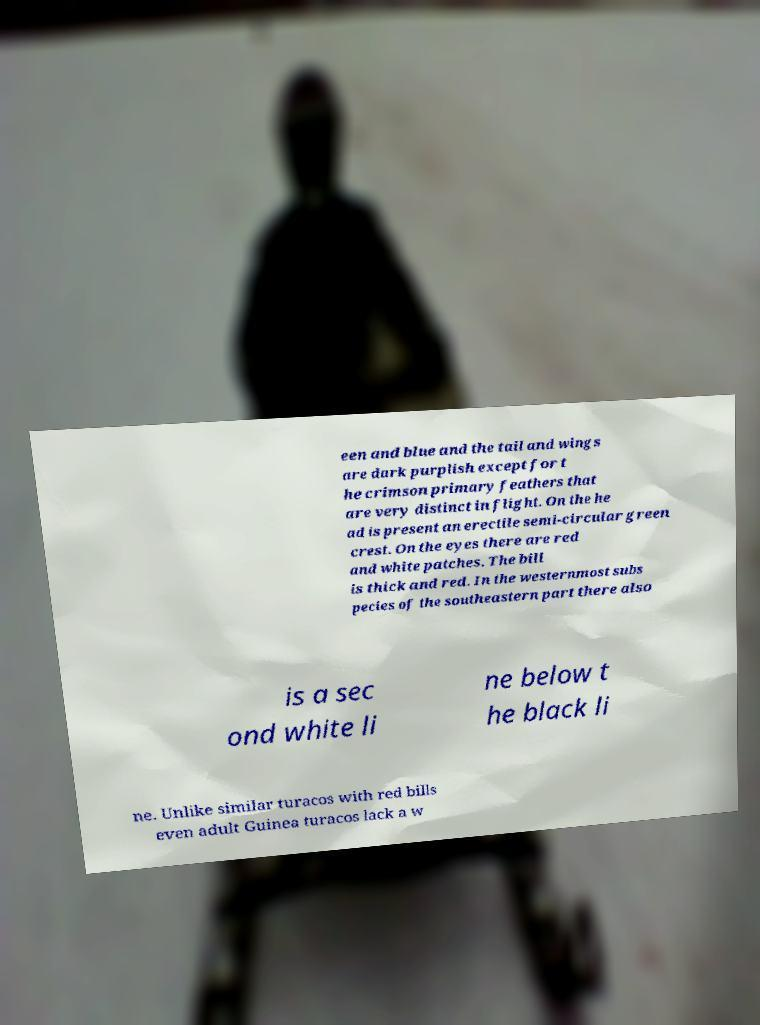There's text embedded in this image that I need extracted. Can you transcribe it verbatim? een and blue and the tail and wings are dark purplish except for t he crimson primary feathers that are very distinct in flight. On the he ad is present an erectile semi-circular green crest. On the eyes there are red and white patches. The bill is thick and red. In the westernmost subs pecies of the southeastern part there also is a sec ond white li ne below t he black li ne. Unlike similar turacos with red bills even adult Guinea turacos lack a w 